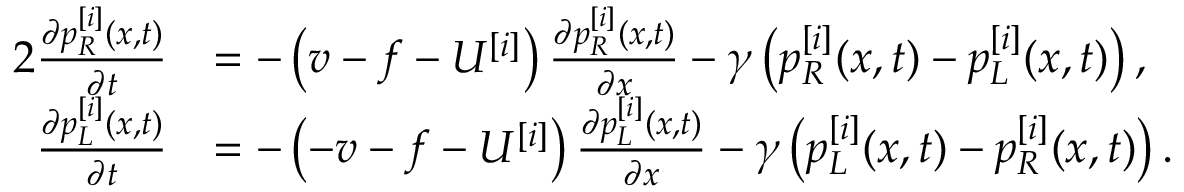<formula> <loc_0><loc_0><loc_500><loc_500>\begin{array} { r l } { { 2 } \frac { \partial p _ { R } ^ { [ i ] } ( x , t ) } { \partial t } } & { = - \left ( v - f - U ^ { [ i ] } \right ) \frac { \partial p _ { R } ^ { [ i ] } ( x , t ) } { \partial x } - \gamma \left ( p _ { R } ^ { [ i ] } ( x , t ) - p _ { L } ^ { [ i ] } ( x , t ) \right ) , } \\ { \frac { \partial p _ { L } ^ { [ i ] } ( x , t ) } { \partial t } } & { = - \left ( - v - f - U ^ { [ i ] } \right ) \frac { \partial p _ { L } ^ { [ i ] } ( x , t ) } { \partial x } - \gamma \left ( p _ { L } ^ { [ i ] } ( x , t ) - p _ { R } ^ { [ i ] } ( x , t ) \right ) . } \end{array}</formula> 